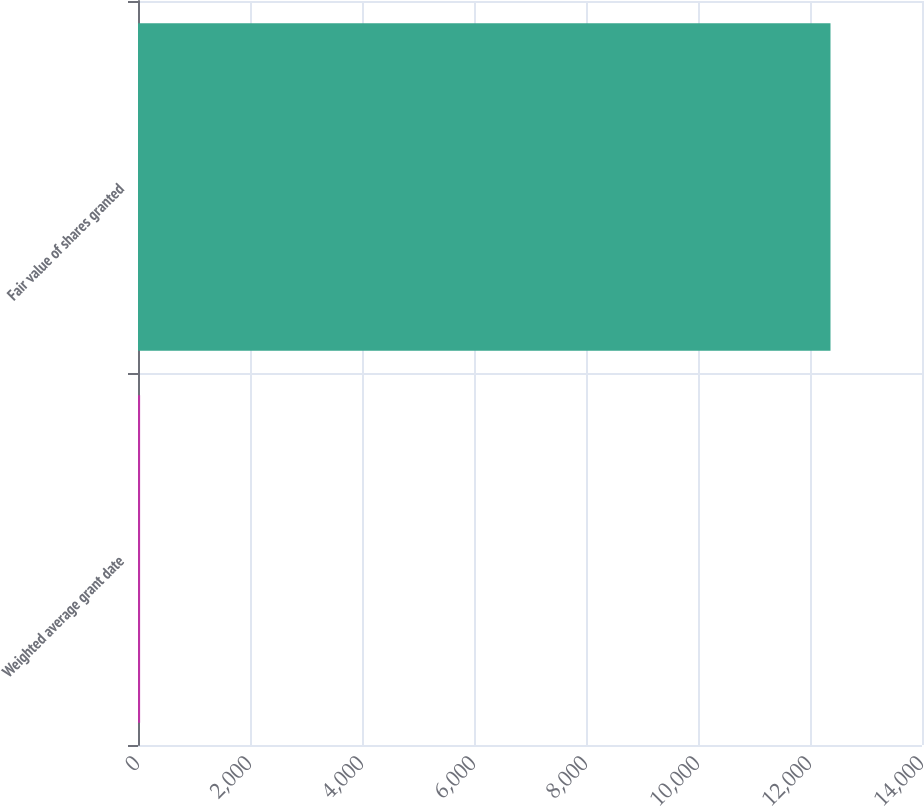Convert chart. <chart><loc_0><loc_0><loc_500><loc_500><bar_chart><fcel>Weighted average grant date<fcel>Fair value of shares granted<nl><fcel>37.58<fcel>12366<nl></chart> 